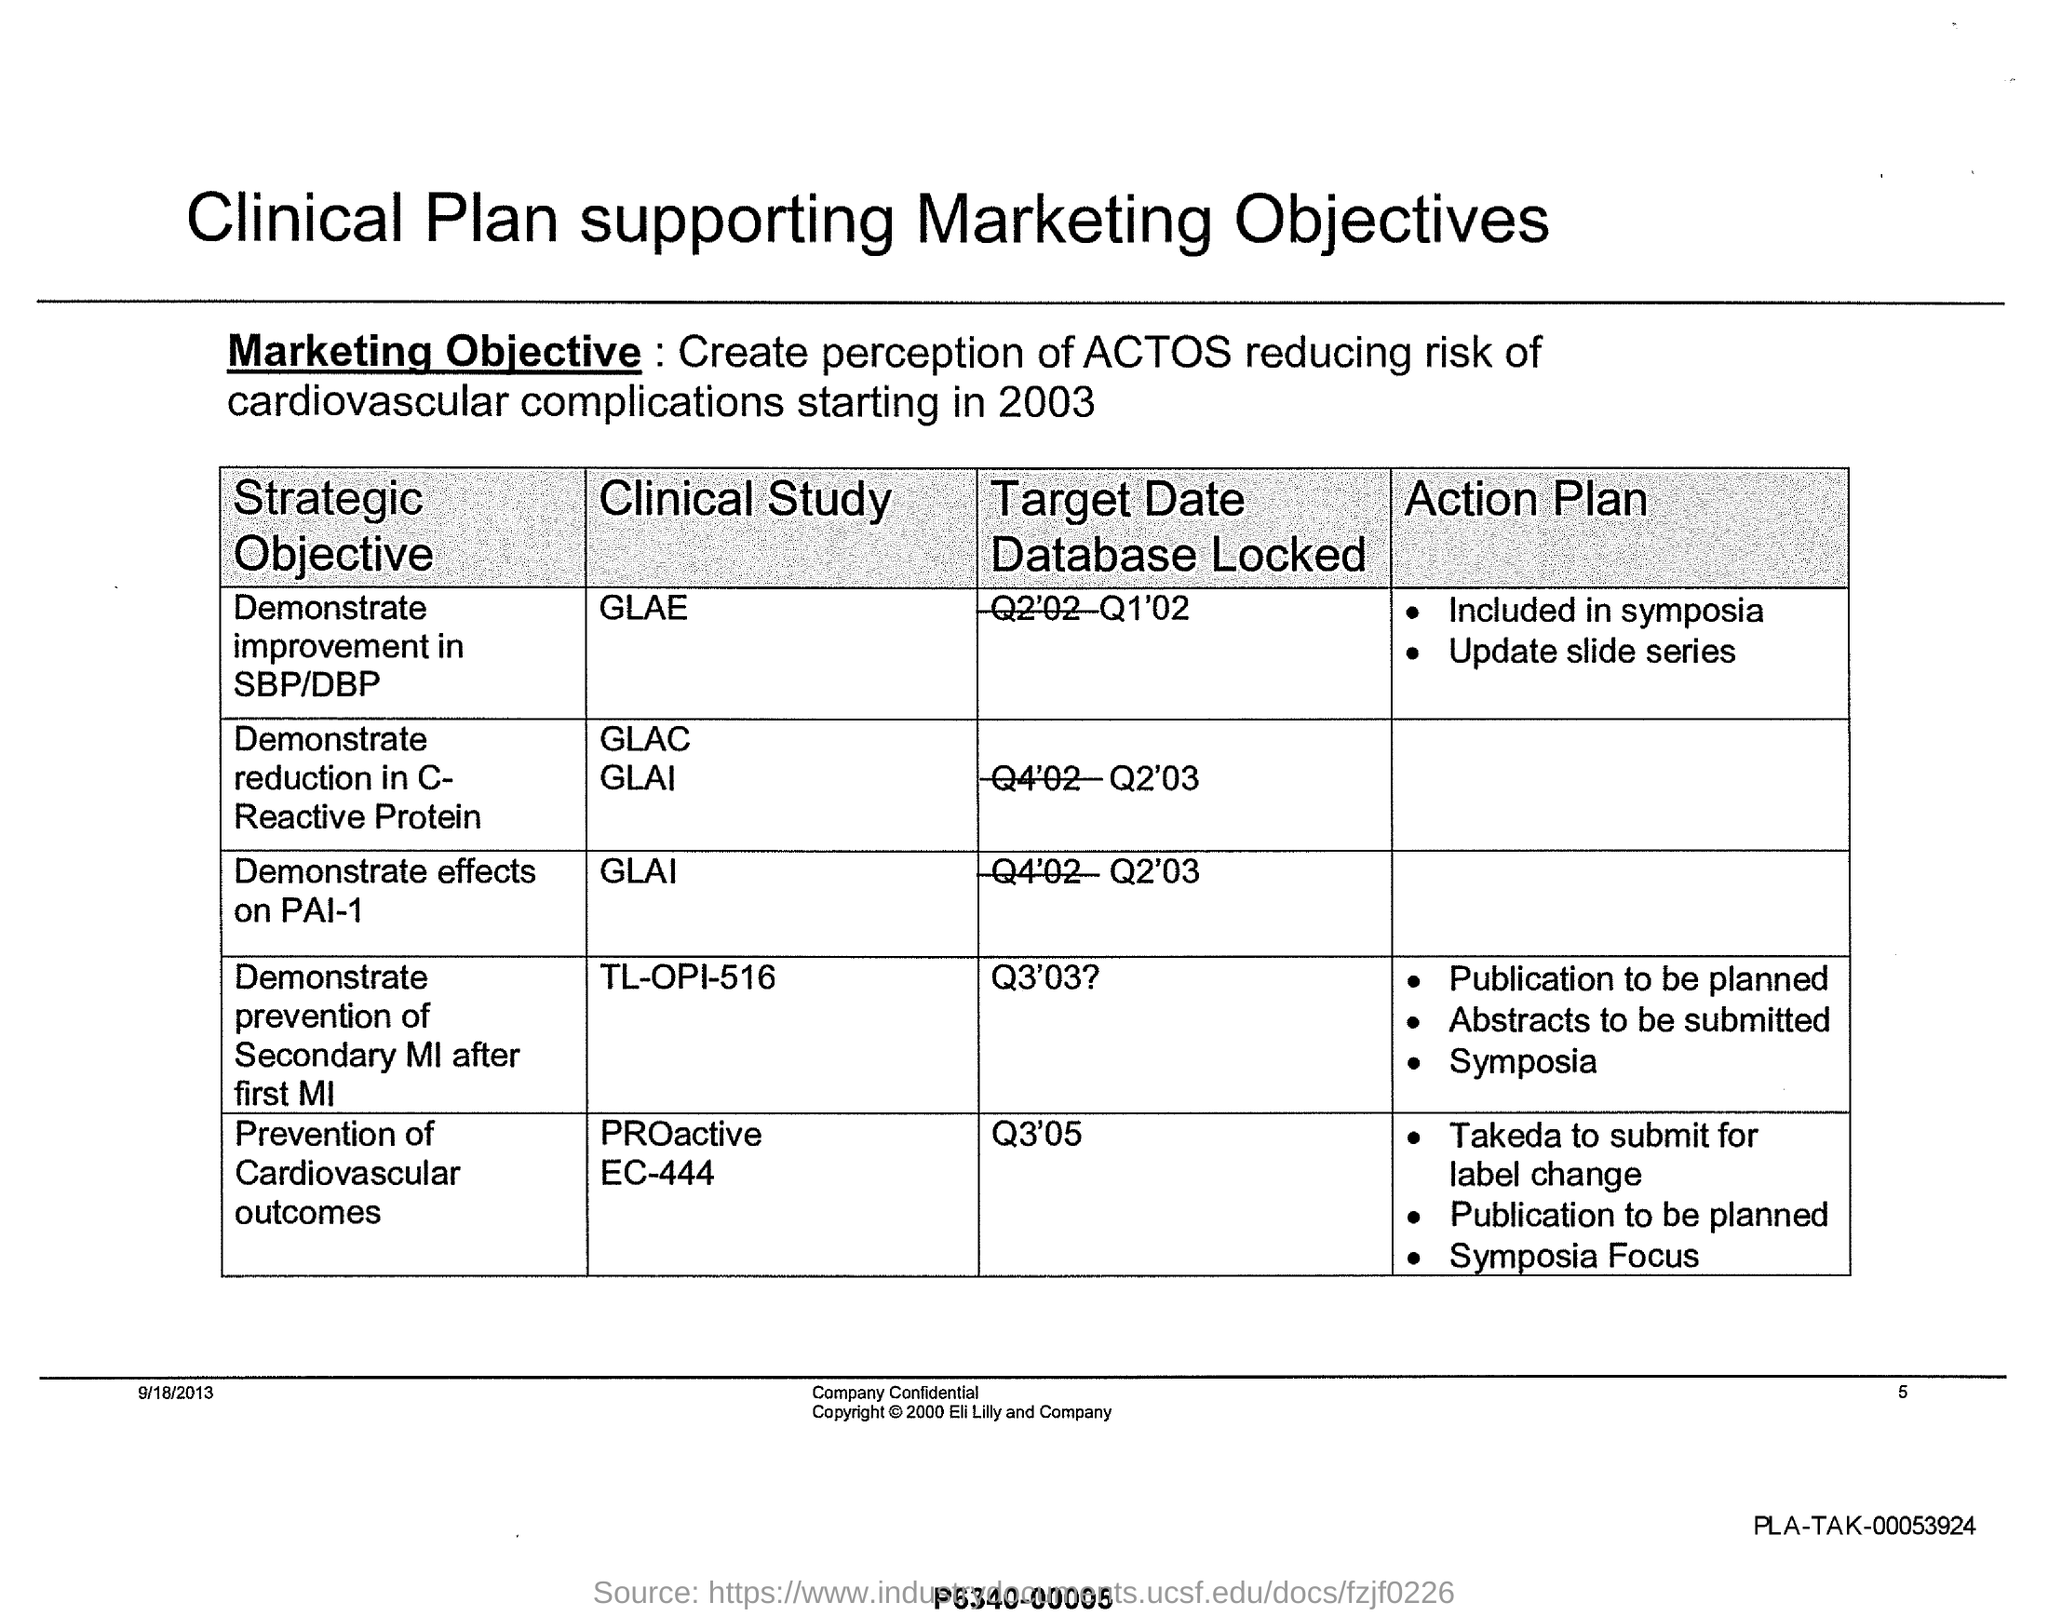Indicate a few pertinent items in this graphic. A clinical study with a target date database locked to Q1'02 is being conducted. The strategic objective of the Clinical study "GLAE" is to demonstrate a significant improvement in both systolic blood pressure (SBP) and diastolic blood pressure (DBP) compared to previous studies. The strategic objective of the clinical study "TL-OPI-516" is to demonstrate the prevention of secondary myocardial infarction (MI) after a first MI. The marketing objective mentioned in the document is to create a perception that ACTOS reduces the risk of cardiovascular complications starting in 2003. The target date for locking the database for the clinical study 'GLAI' has been set for Q2 2003. 